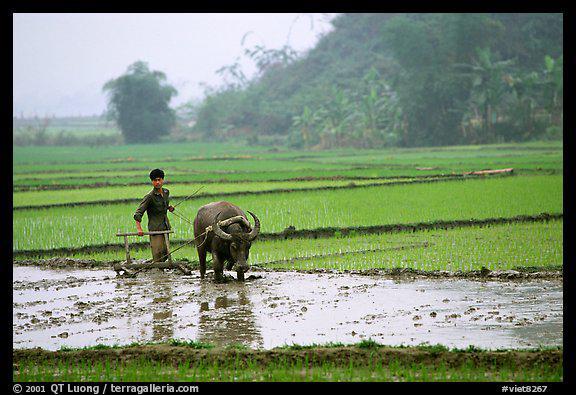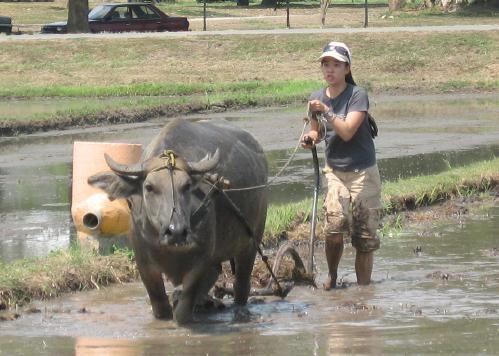The first image is the image on the left, the second image is the image on the right. Analyze the images presented: Is the assertion "Each image shows a person walking behind an ox pulling a tiller" valid? Answer yes or no. Yes. The first image is the image on the left, the second image is the image on the right. Examine the images to the left and right. Is the description "The right image shows one woman walking leftward behind a plow pulled by one ox through a wet field, and the left image shows one man walking rightward behind a plow pulled by one ox through a wet field." accurate? Answer yes or no. Yes. 